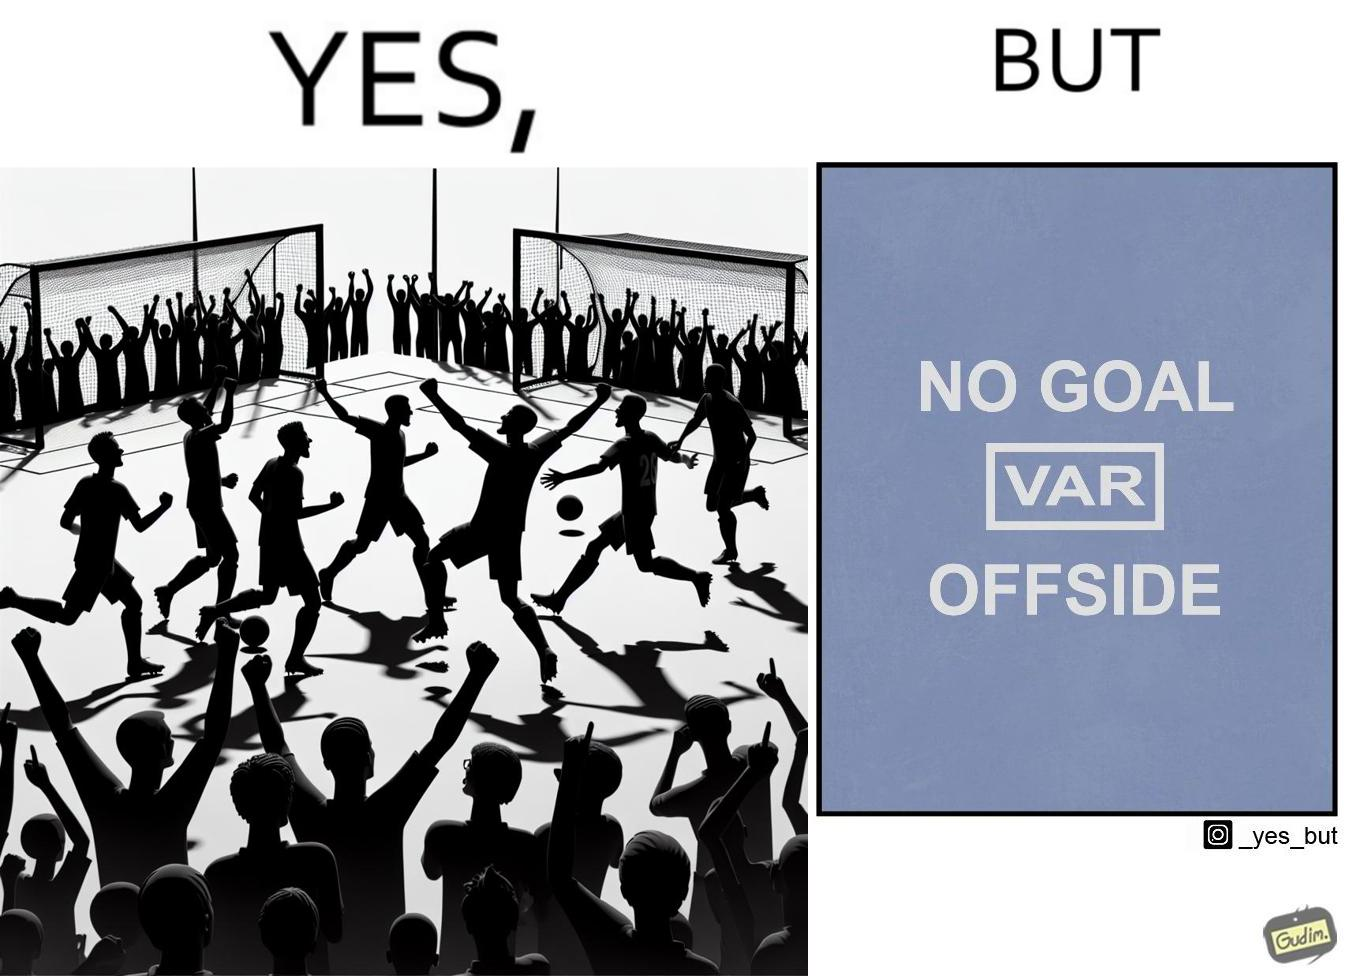Does this image contain satire or humor? Yes, this image is satirical. 